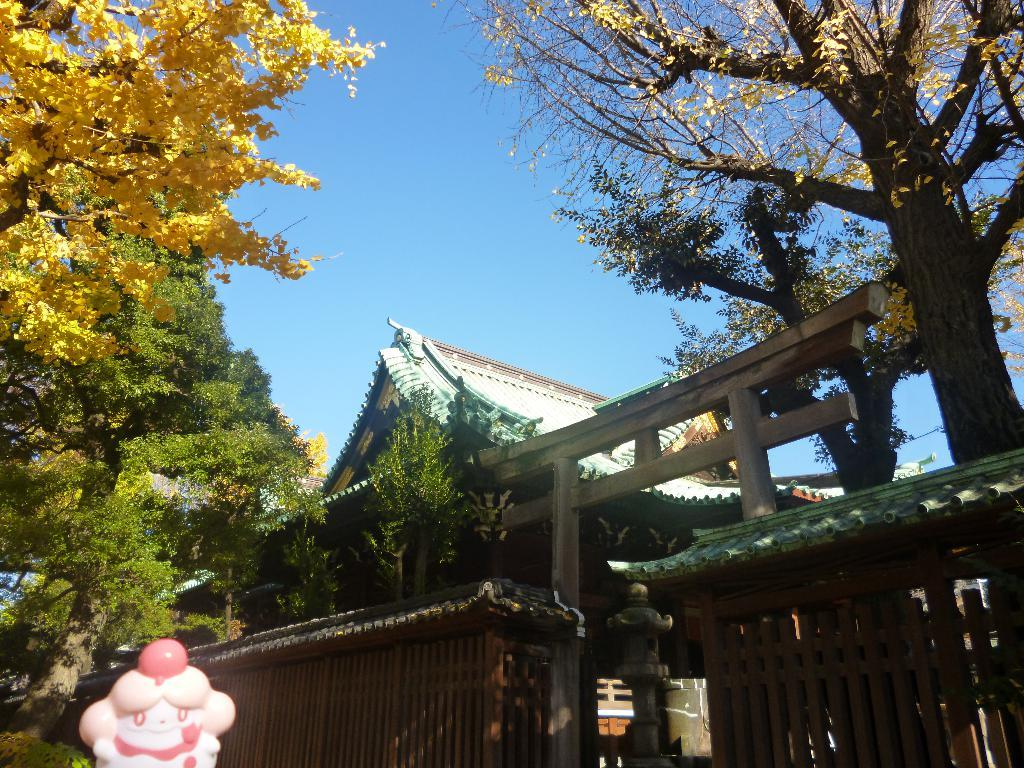What type of vegetation can be seen in the image? There are trees in the image. What structure is visible in the image? There is a compound wall in the image. What color is the sky in the image? The sky is blue in the image. What grade is the lettuce in the image? There is no lettuce present in the image. 